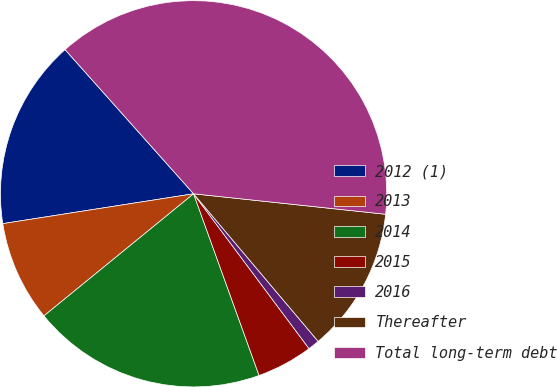Convert chart to OTSL. <chart><loc_0><loc_0><loc_500><loc_500><pie_chart><fcel>2012 (1)<fcel>2013<fcel>2014<fcel>2015<fcel>2016<fcel>Thereafter<fcel>Total long-term debt<nl><fcel>15.88%<fcel>8.42%<fcel>19.61%<fcel>4.69%<fcel>0.96%<fcel>12.15%<fcel>38.27%<nl></chart> 